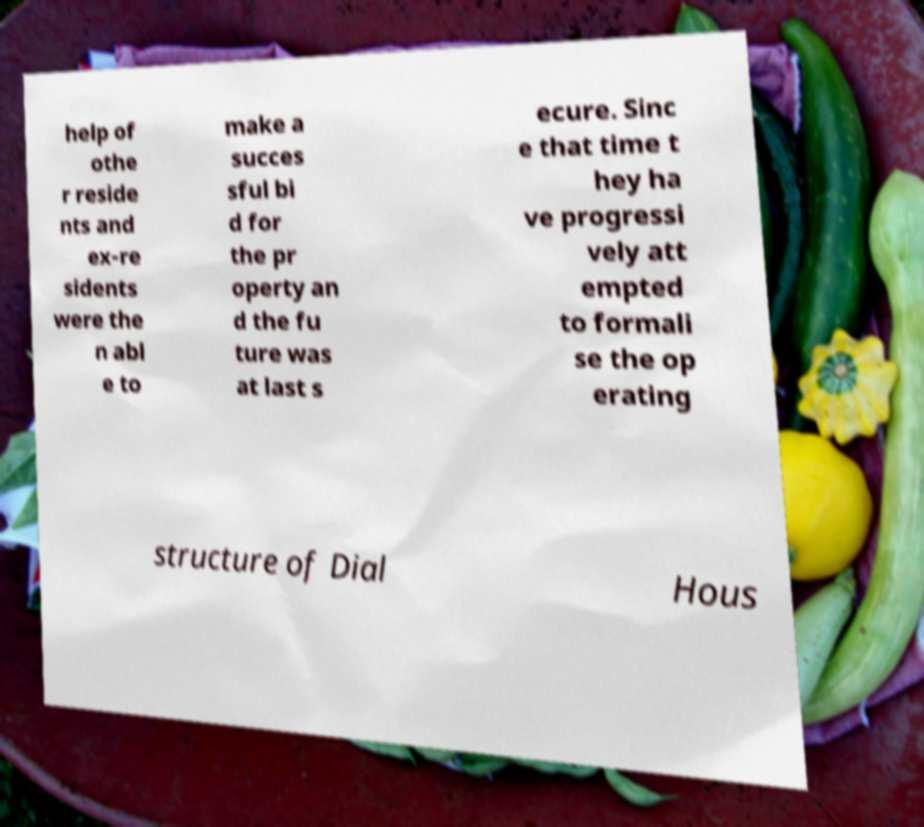For documentation purposes, I need the text within this image transcribed. Could you provide that? help of othe r reside nts and ex-re sidents were the n abl e to make a succes sful bi d for the pr operty an d the fu ture was at last s ecure. Sinc e that time t hey ha ve progressi vely att empted to formali se the op erating structure of Dial Hous 